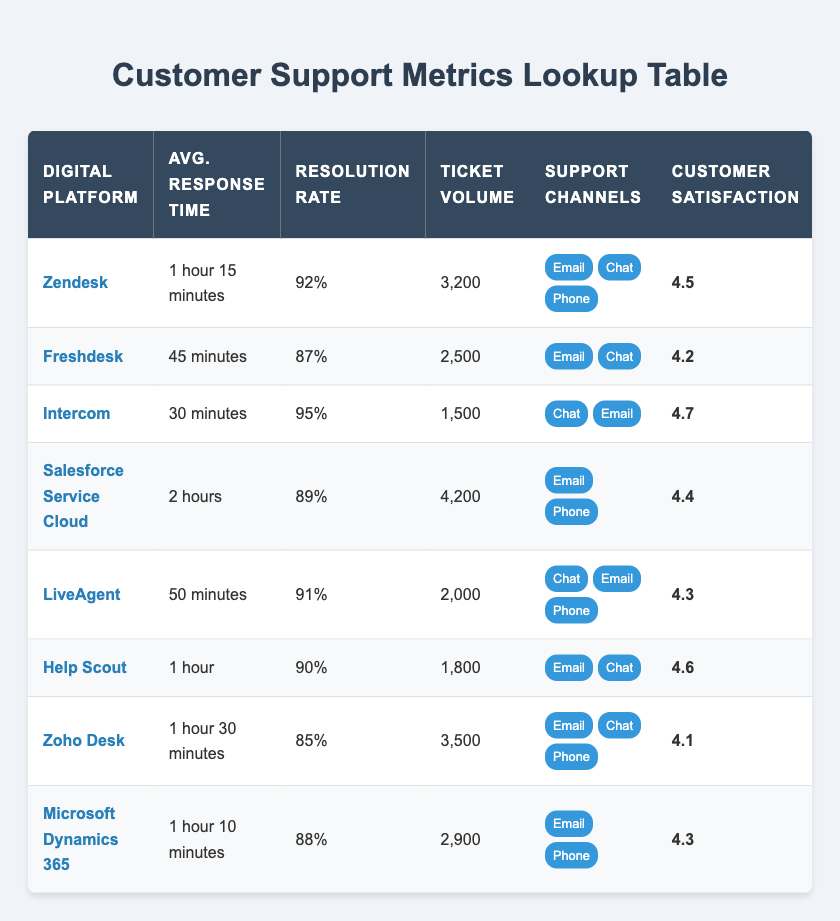What is the average response time for the platform with the highest resolution rate? The platform with the highest resolution rate is Intercom, which has an average response time of 30 minutes.
Answer: 30 minutes Which platform has the lowest customer satisfaction score? By examining the table, Zoho Desk has the lowest customer satisfaction score of 4.1.
Answer: 4.1 What is the total ticket volume for all platforms? To find the total ticket volume, we sum the ticket volumes of all platforms: 3200 + 2500 + 1500 + 4200 + 2000 + 1800 + 3500 + 2900 = 20600.
Answer: 20600 Is the average response time for Freshdesk shorter than that of Zendesk? Freshdesk's average response time is 45 minutes, which is shorter than Zendesk's average response time of 1 hour 15 minutes (75 minutes). Therefore, the statement is true.
Answer: Yes Which platform has the highest ticket volume and what is its resolution rate? Salesforce Service Cloud has the highest ticket volume at 4200. Its resolution rate is 89%.
Answer: 4200 tickets, 89% resolution rate What is the difference in customer satisfaction scores between the platforms with the highest and lowest resolution rates? The highest resolution rate is from Intercom at 95% and the lowest from Zoho Desk at 85%. Their customer satisfaction scores are 4.7 and 4.1 respectively. The difference is 4.7 - 4.1 = 0.6.
Answer: 0.6 Which platform offers the most support channels? The platform with the most support channels is Zendesk, which offers three support channels: Email, Chat, and Phone.
Answer: Zendesk What is the average resolution rate of all platforms listed? To find the average resolution rate, we sum the resolution rates: 92% + 87% + 95% + 89% + 91% + 90% + 85% + 88% = 716%. There are 8 platforms, so the average resolution rate is 716% / 8 = 89.5%.
Answer: 89.5% 